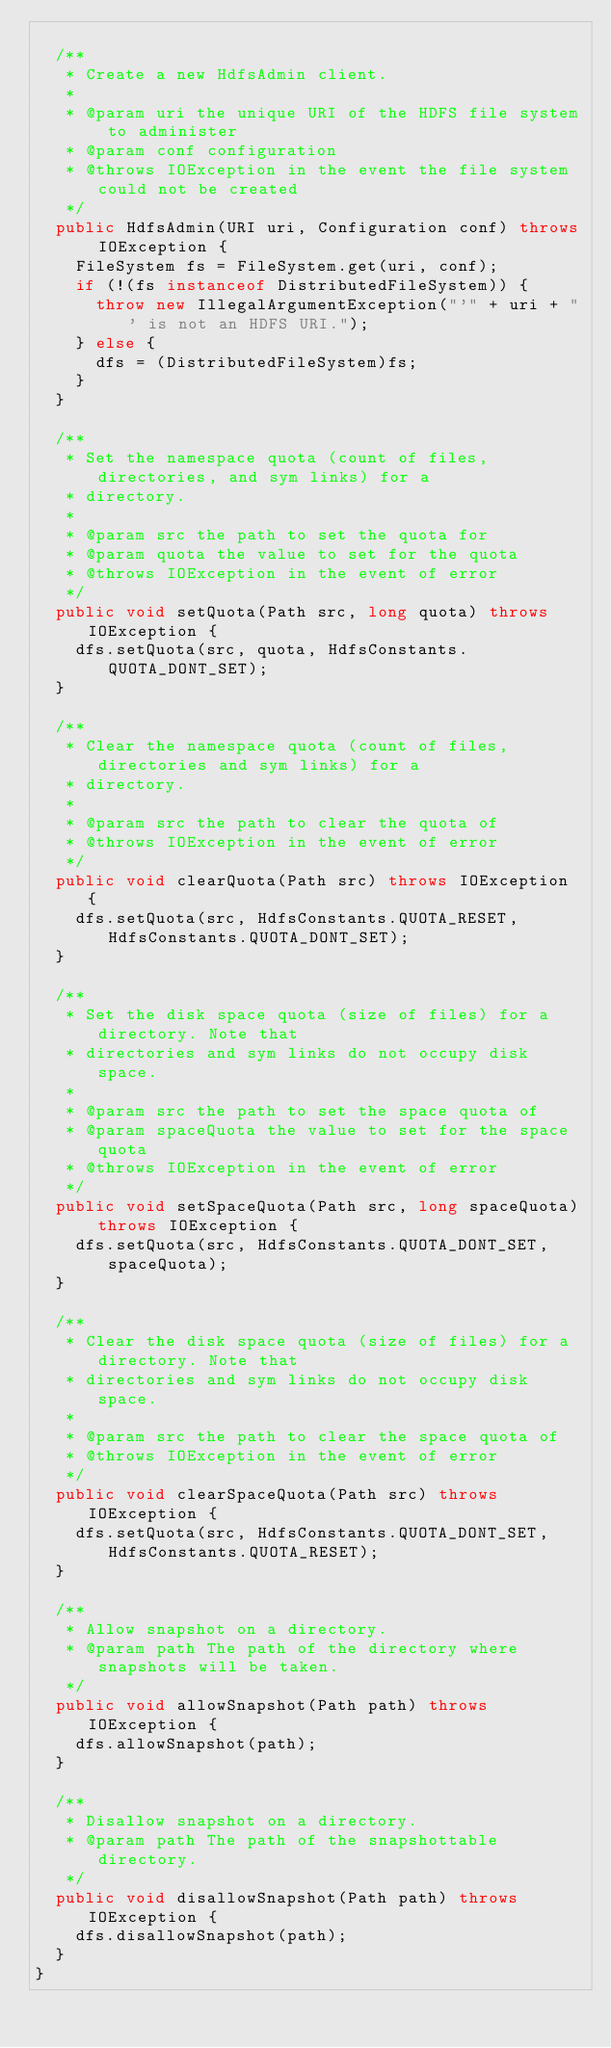<code> <loc_0><loc_0><loc_500><loc_500><_Java_>  
  /**
   * Create a new HdfsAdmin client.
   * 
   * @param uri the unique URI of the HDFS file system to administer
   * @param conf configuration
   * @throws IOException in the event the file system could not be created
   */
  public HdfsAdmin(URI uri, Configuration conf) throws IOException {
    FileSystem fs = FileSystem.get(uri, conf);
    if (!(fs instanceof DistributedFileSystem)) {
      throw new IllegalArgumentException("'" + uri + "' is not an HDFS URI.");
    } else {
      dfs = (DistributedFileSystem)fs;
    }
  }
  
  /**
   * Set the namespace quota (count of files, directories, and sym links) for a
   * directory.
   * 
   * @param src the path to set the quota for
   * @param quota the value to set for the quota
   * @throws IOException in the event of error
   */
  public void setQuota(Path src, long quota) throws IOException {
    dfs.setQuota(src, quota, HdfsConstants.QUOTA_DONT_SET);
  }
  
  /**
   * Clear the namespace quota (count of files, directories and sym links) for a
   * directory.
   * 
   * @param src the path to clear the quota of
   * @throws IOException in the event of error
   */
  public void clearQuota(Path src) throws IOException {
    dfs.setQuota(src, HdfsConstants.QUOTA_RESET, HdfsConstants.QUOTA_DONT_SET);
  }
  
  /**
   * Set the disk space quota (size of files) for a directory. Note that
   * directories and sym links do not occupy disk space.
   * 
   * @param src the path to set the space quota of
   * @param spaceQuota the value to set for the space quota
   * @throws IOException in the event of error
   */
  public void setSpaceQuota(Path src, long spaceQuota) throws IOException {
    dfs.setQuota(src, HdfsConstants.QUOTA_DONT_SET, spaceQuota);
  }
  
  /**
   * Clear the disk space quota (size of files) for a directory. Note that
   * directories and sym links do not occupy disk space.
   * 
   * @param src the path to clear the space quota of
   * @throws IOException in the event of error
   */
  public void clearSpaceQuota(Path src) throws IOException {
    dfs.setQuota(src, HdfsConstants.QUOTA_DONT_SET, HdfsConstants.QUOTA_RESET);
  }
  
  /**
   * Allow snapshot on a directory.
   * @param path The path of the directory where snapshots will be taken.
   */
  public void allowSnapshot(Path path) throws IOException {
    dfs.allowSnapshot(path);
  }
  
  /**
   * Disallow snapshot on a directory.
   * @param path The path of the snapshottable directory.
   */
  public void disallowSnapshot(Path path) throws IOException {
    dfs.disallowSnapshot(path);
  }
}
</code> 